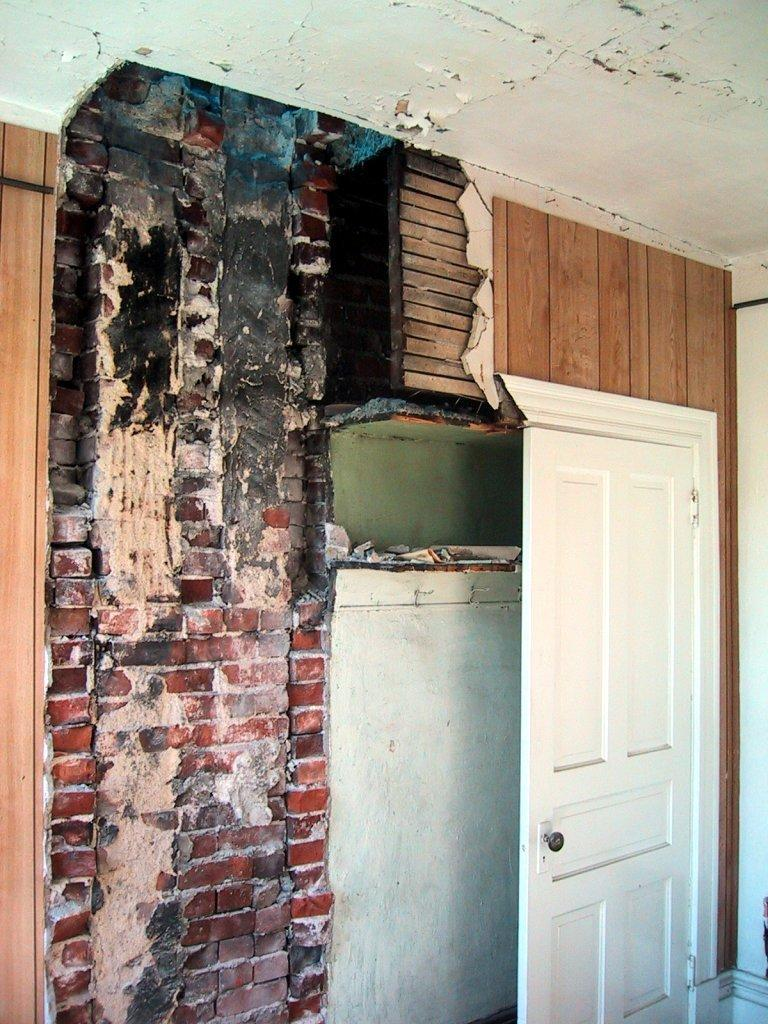What is the main feature in the center of the image? There is a broken wall in the center of the image. Can you describe any other architectural elements in the image? Yes, there is a door in the image. What can be seen at the top of the image? There is a ceiling visible at the top of the image. How many nails are holding the basket in the image? There is no basket present in the image, so it is not possible to determine the number of nails holding it. 